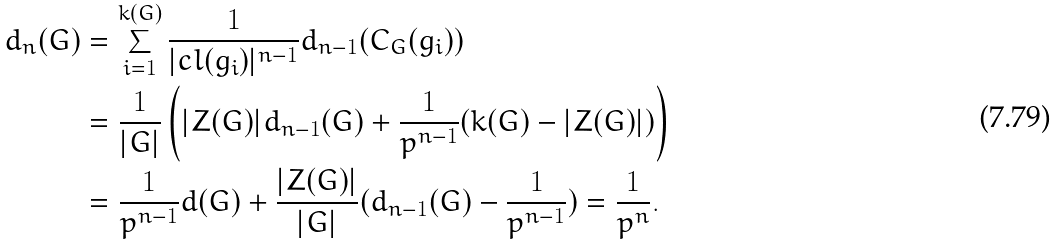<formula> <loc_0><loc_0><loc_500><loc_500>d _ { n } ( G ) & = \sum _ { i = 1 } ^ { k ( G ) } \frac { 1 } { | c l ( g _ { i } ) | ^ { n - 1 } } d _ { n - 1 } ( C _ { G } ( g _ { i } ) ) \\ & = \frac { 1 } { | G | } \left ( | Z ( G ) | d _ { n - 1 } ( G ) + \frac { 1 } { p ^ { n - 1 } } ( k ( G ) - | Z ( G ) | ) \right ) \\ & = \frac { 1 } { p ^ { n - 1 } } d ( G ) + \frac { | Z ( G ) | } { | G | } ( d _ { n - 1 } ( G ) - \frac { 1 } { p ^ { n - 1 } } ) = \frac { 1 } { p ^ { n } } .</formula> 